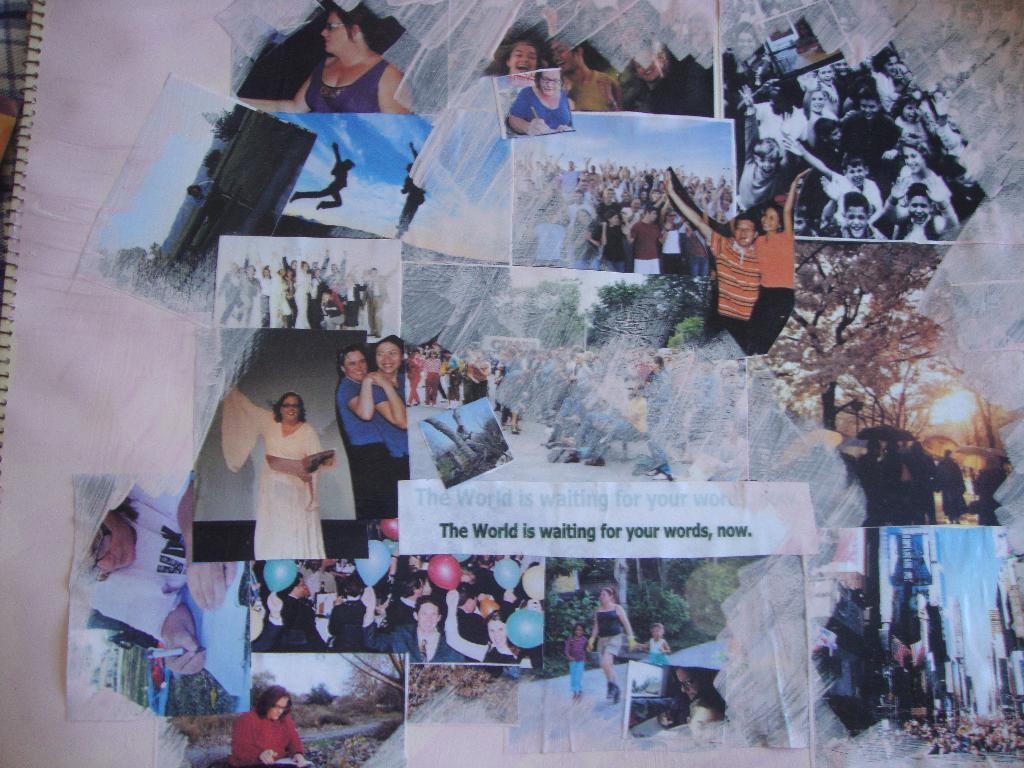<image>
Offer a succinct explanation of the picture presented. A collage collection of a variety of people with the quote the world is waiting for your words, now. 